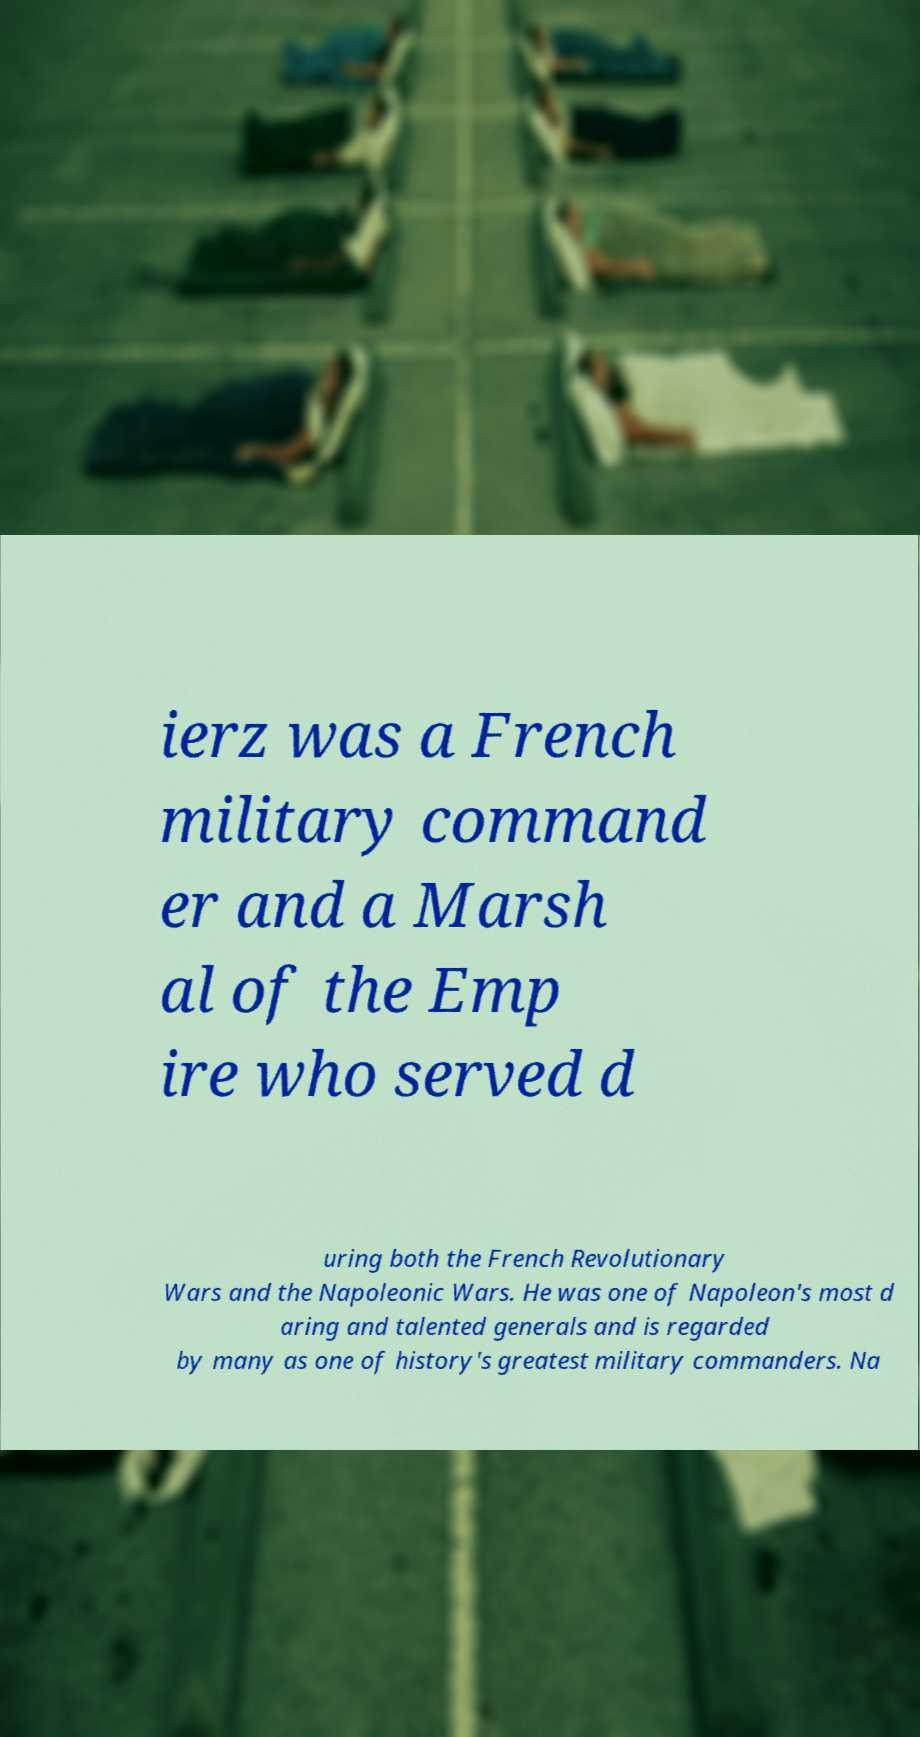Could you assist in decoding the text presented in this image and type it out clearly? ierz was a French military command er and a Marsh al of the Emp ire who served d uring both the French Revolutionary Wars and the Napoleonic Wars. He was one of Napoleon's most d aring and talented generals and is regarded by many as one of history's greatest military commanders. Na 